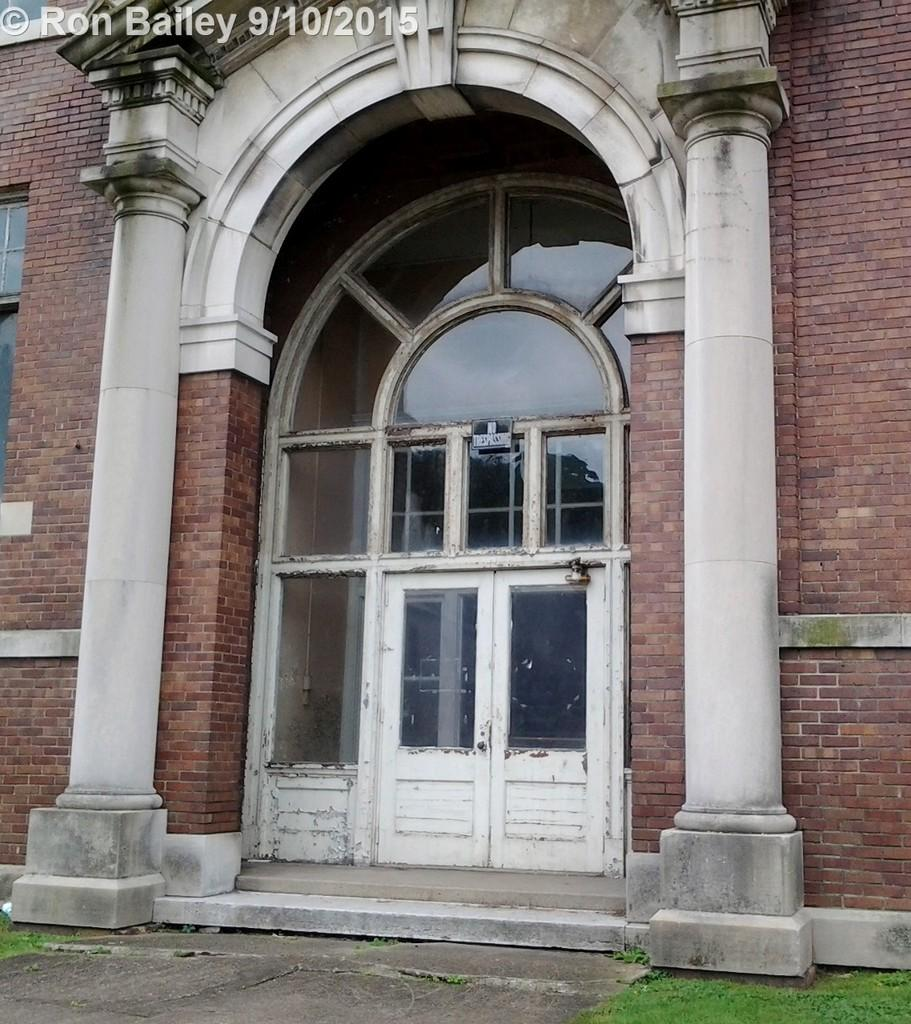What type of structure can be seen in the image? There is a door in the image, which suggests a structure. What architectural elements are present in the image? There are pillars in the image. What type of natural environment is visible in the image? There is grass in the image. What surface is visible in the image? There is a floor in the image. What type of jewel is hanging from the door in the image? There is no jewel hanging from the door in the image. How many chairs are visible in the image? There are no chairs present in the image. 